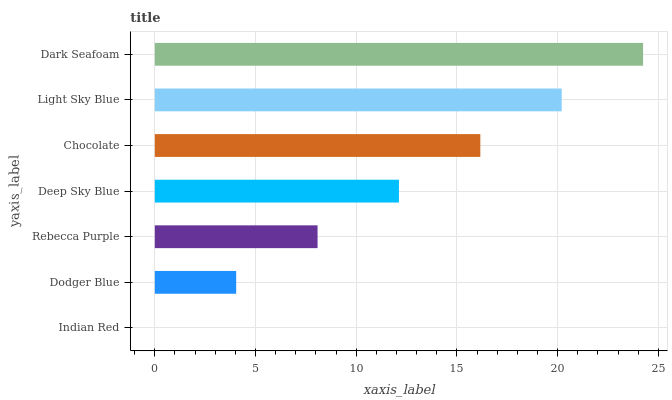Is Indian Red the minimum?
Answer yes or no. Yes. Is Dark Seafoam the maximum?
Answer yes or no. Yes. Is Dodger Blue the minimum?
Answer yes or no. No. Is Dodger Blue the maximum?
Answer yes or no. No. Is Dodger Blue greater than Indian Red?
Answer yes or no. Yes. Is Indian Red less than Dodger Blue?
Answer yes or no. Yes. Is Indian Red greater than Dodger Blue?
Answer yes or no. No. Is Dodger Blue less than Indian Red?
Answer yes or no. No. Is Deep Sky Blue the high median?
Answer yes or no. Yes. Is Deep Sky Blue the low median?
Answer yes or no. Yes. Is Dodger Blue the high median?
Answer yes or no. No. Is Dodger Blue the low median?
Answer yes or no. No. 